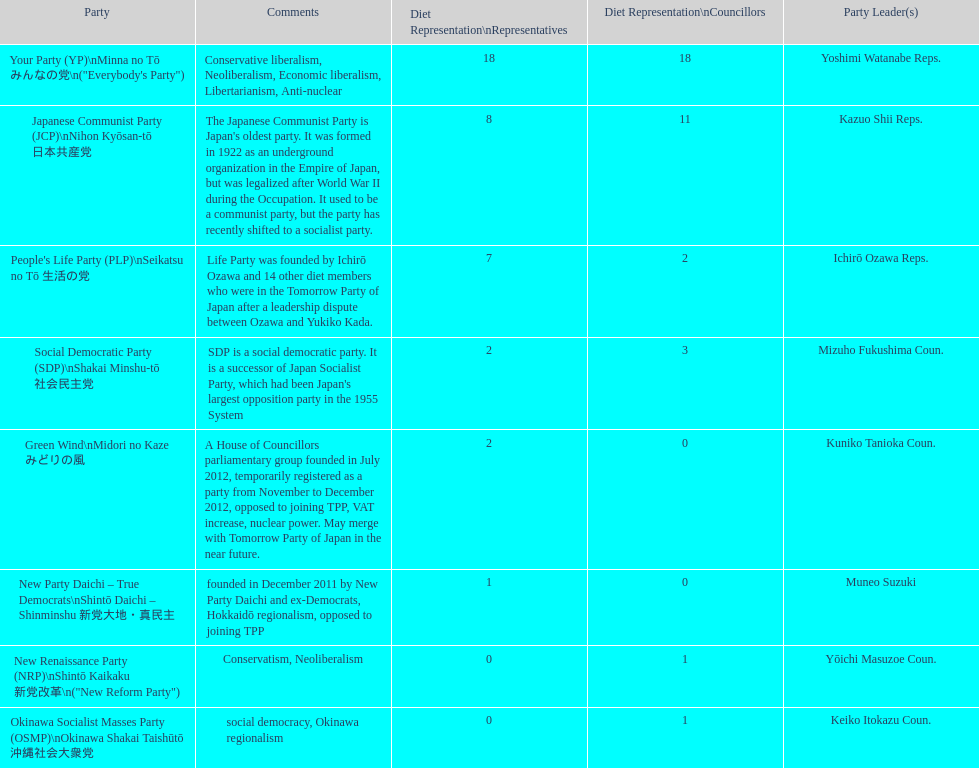How many of these parties currently have no councillors? 2. 